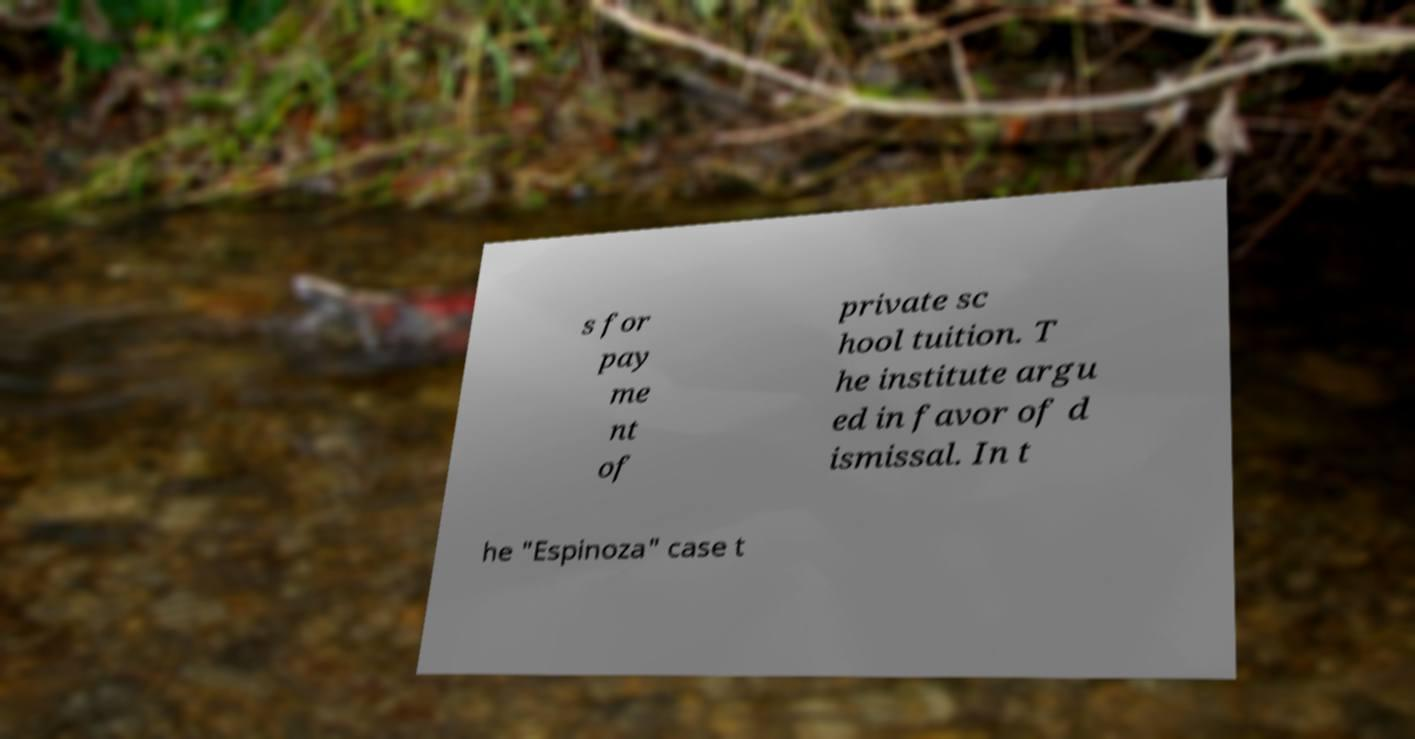Could you extract and type out the text from this image? s for pay me nt of private sc hool tuition. T he institute argu ed in favor of d ismissal. In t he "Espinoza" case t 